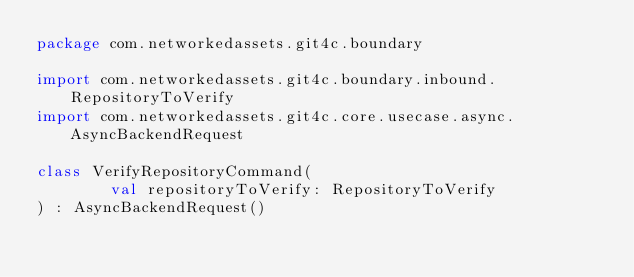Convert code to text. <code><loc_0><loc_0><loc_500><loc_500><_Kotlin_>package com.networkedassets.git4c.boundary

import com.networkedassets.git4c.boundary.inbound.RepositoryToVerify
import com.networkedassets.git4c.core.usecase.async.AsyncBackendRequest

class VerifyRepositoryCommand(
        val repositoryToVerify: RepositoryToVerify
) : AsyncBackendRequest()</code> 